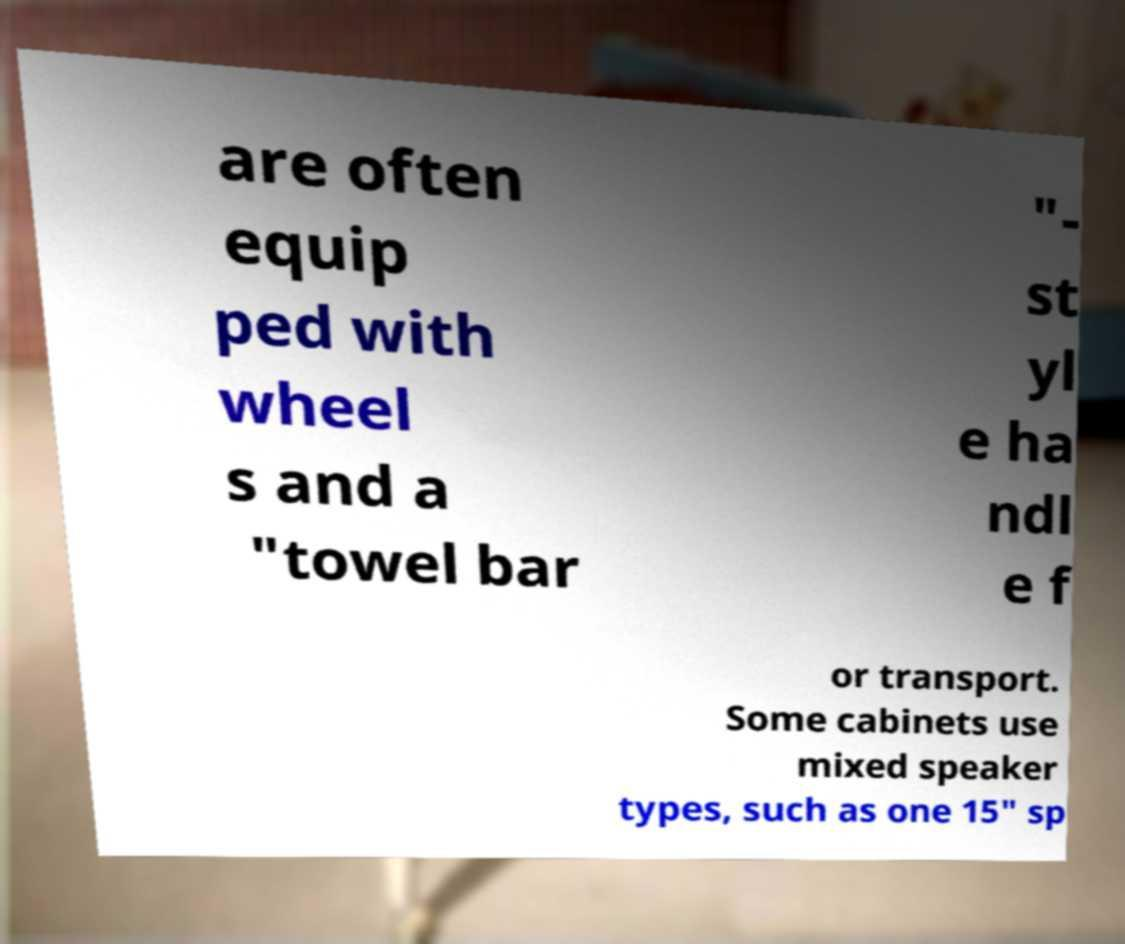Could you extract and type out the text from this image? are often equip ped with wheel s and a "towel bar "- st yl e ha ndl e f or transport. Some cabinets use mixed speaker types, such as one 15" sp 